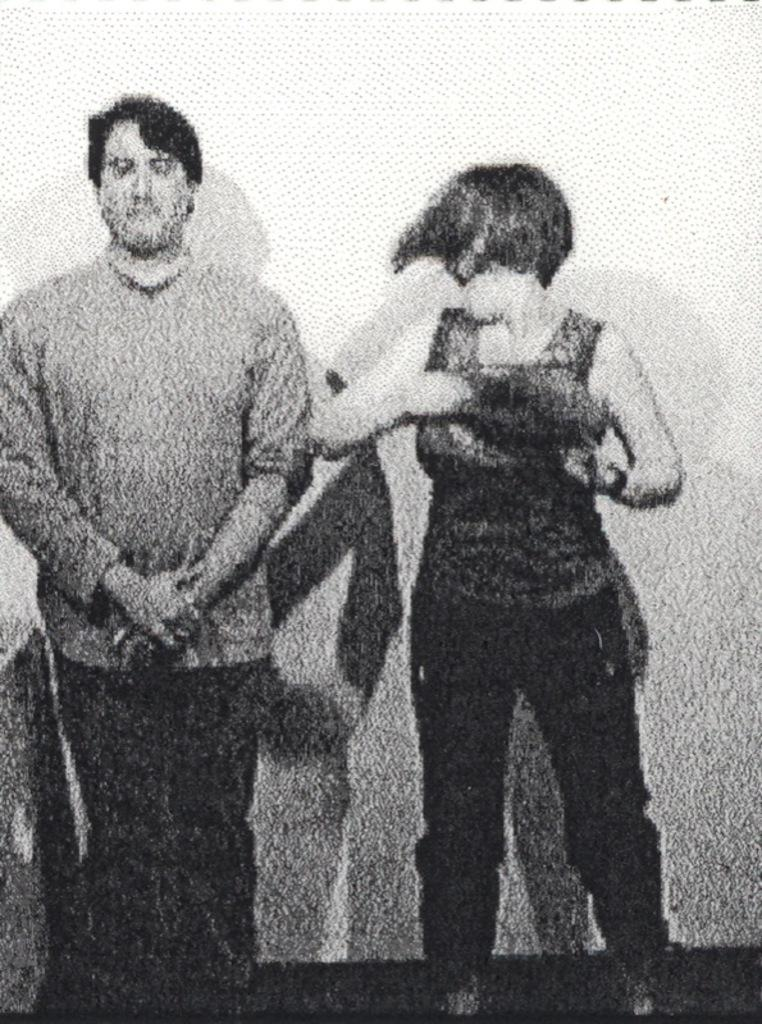How many people are present in the image? There are two people in the image, a man and a woman. What are the positions of the man and the woman in the image? Both the man and the woman are standing in the image. What type of degree does the man have in the image? There is no indication of any degrees in the image, as it only shows a man and a woman standing. 